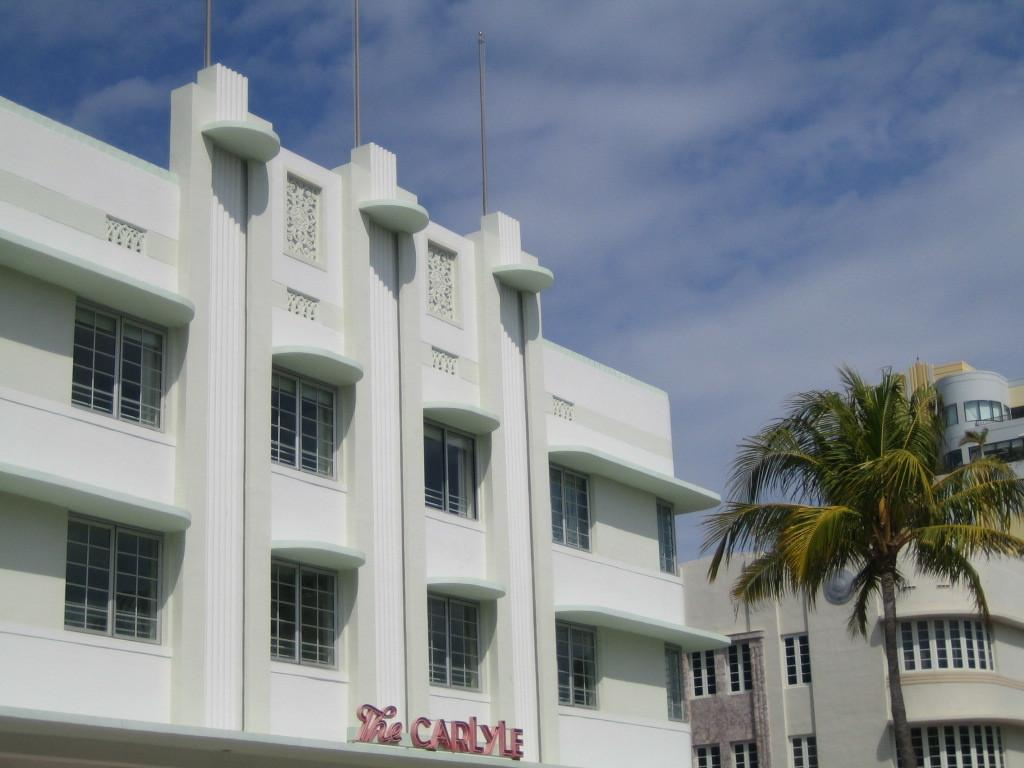What type of structures can be seen in the background of the image? There are buildings in the background of the image. What is located in front of the buildings? There is a tree in front of the buildings. What part of the natural environment is visible in the image? The sky is visible in the image. What can be observed in the sky? Clouds are present in the sky. Can you tell me how many toes are visible on the tree in the image? There are no toes present in the image, as it features buildings, a tree, and clouds in the sky. What type of fight is taking place in the image? There is no fight depicted in the image; it shows a tree in front of buildings with clouds in the sky. 